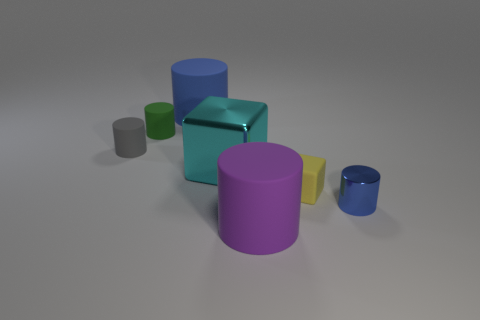There is a cylinder that is the same color as the tiny shiny object; what size is it?
Your answer should be compact. Large. What size is the object that is both behind the tiny gray thing and in front of the blue matte object?
Provide a succinct answer. Small. How many rubber cylinders are right of the gray thing behind the big matte cylinder that is on the right side of the cyan shiny thing?
Offer a very short reply. 3. Are there any other large metal cubes that have the same color as the large cube?
Your answer should be compact. No. What is the color of the cube that is the same size as the blue metallic object?
Your answer should be compact. Yellow. What is the shape of the rubber object right of the matte thing that is in front of the small blue shiny thing to the right of the cyan metal object?
Offer a terse response. Cube. How many yellow blocks are behind the blue cylinder to the left of the tiny blue cylinder?
Offer a very short reply. 0. Do the object to the left of the tiny green rubber cylinder and the big matte object behind the purple cylinder have the same shape?
Your response must be concise. Yes. What number of green matte cylinders are in front of the large metal cube?
Keep it short and to the point. 0. Are the yellow object on the right side of the green object and the small green cylinder made of the same material?
Make the answer very short. Yes. 